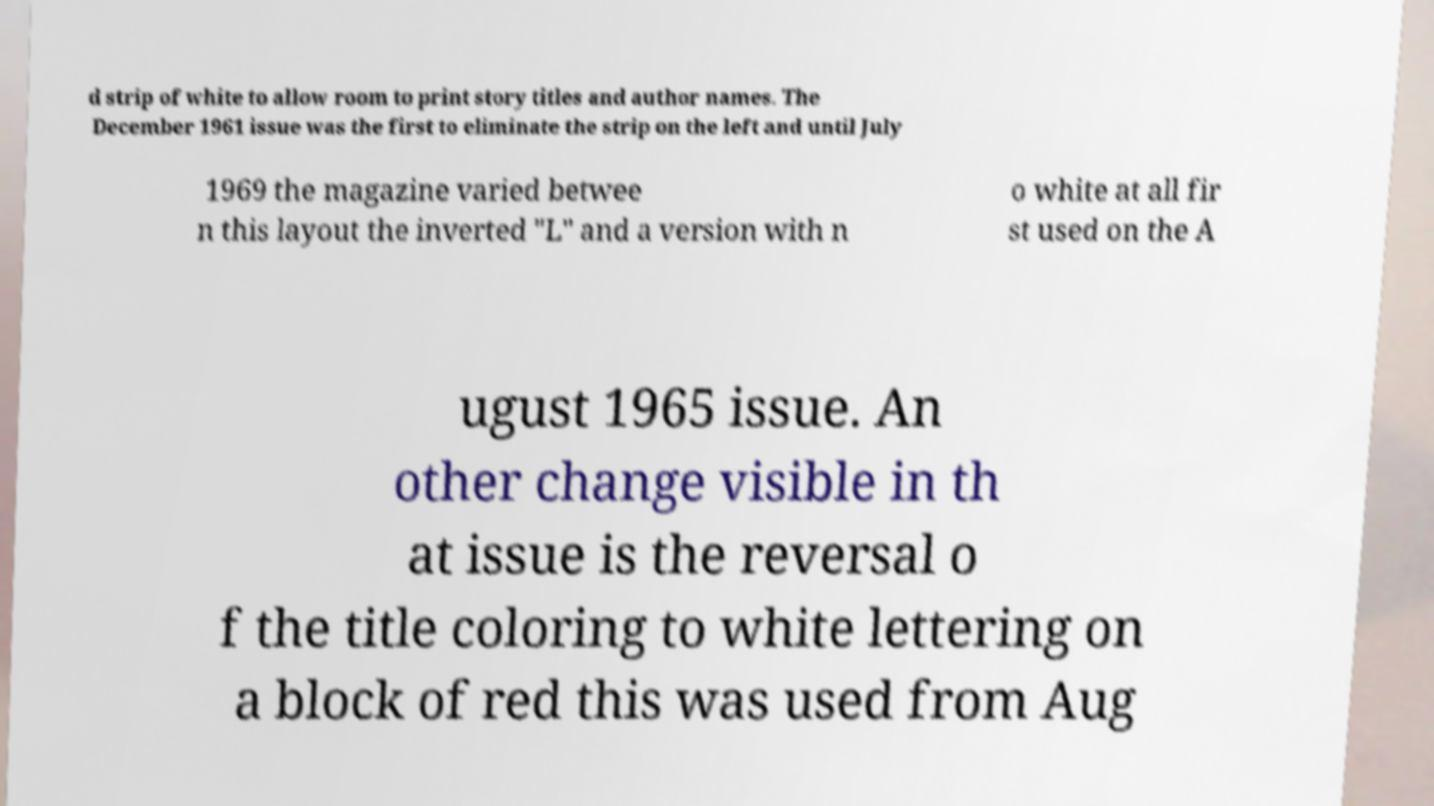I need the written content from this picture converted into text. Can you do that? d strip of white to allow room to print story titles and author names. The December 1961 issue was the first to eliminate the strip on the left and until July 1969 the magazine varied betwee n this layout the inverted "L" and a version with n o white at all fir st used on the A ugust 1965 issue. An other change visible in th at issue is the reversal o f the title coloring to white lettering on a block of red this was used from Aug 